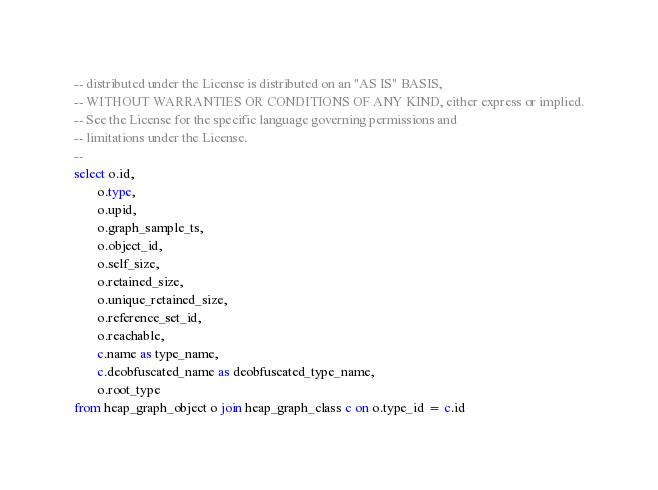<code> <loc_0><loc_0><loc_500><loc_500><_SQL_>-- distributed under the License is distributed on an "AS IS" BASIS,
-- WITHOUT WARRANTIES OR CONDITIONS OF ANY KIND, either express or implied.
-- See the License for the specific language governing permissions and
-- limitations under the License.
--
select o.id,
       o.type,
       o.upid,
       o.graph_sample_ts,
       o.object_id,
       o.self_size,
       o.retained_size,
       o.unique_retained_size,
       o.reference_set_id,
       o.reachable,
       c.name as type_name,
       c.deobfuscated_name as deobfuscated_type_name,
       o.root_type
from heap_graph_object o join heap_graph_class c on o.type_id = c.id
</code> 